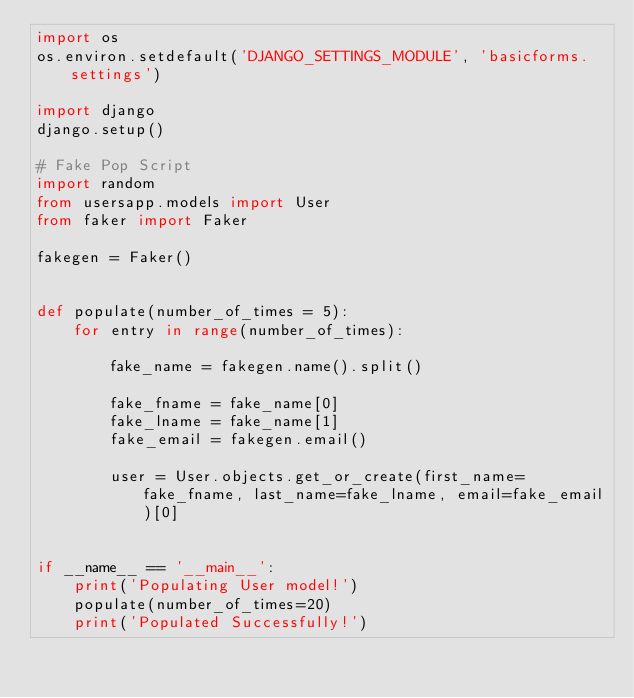<code> <loc_0><loc_0><loc_500><loc_500><_Python_>import os
os.environ.setdefault('DJANGO_SETTINGS_MODULE', 'basicforms.settings')

import django
django.setup()

# Fake Pop Script
import random
from usersapp.models import User
from faker import Faker

fakegen = Faker()


def populate(number_of_times = 5):
    for entry in range(number_of_times):

        fake_name = fakegen.name().split()

        fake_fname = fake_name[0]
        fake_lname = fake_name[1]
        fake_email = fakegen.email()

        user = User.objects.get_or_create(first_name=fake_fname, last_name=fake_lname, email=fake_email)[0]


if __name__ == '__main__':
    print('Populating User model!')
    populate(number_of_times=20)
    print('Populated Successfully!')

</code> 